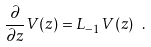Convert formula to latex. <formula><loc_0><loc_0><loc_500><loc_500>\frac { \partial } { \partial z } V ( z ) = L _ { - 1 } V ( z ) \ .</formula> 